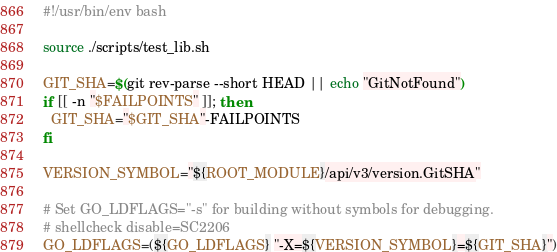Convert code to text. <code><loc_0><loc_0><loc_500><loc_500><_Bash_>#!/usr/bin/env bash

source ./scripts/test_lib.sh

GIT_SHA=$(git rev-parse --short HEAD || echo "GitNotFound")
if [[ -n "$FAILPOINTS" ]]; then
  GIT_SHA="$GIT_SHA"-FAILPOINTS
fi

VERSION_SYMBOL="${ROOT_MODULE}/api/v3/version.GitSHA"

# Set GO_LDFLAGS="-s" for building without symbols for debugging.
# shellcheck disable=SC2206
GO_LDFLAGS=(${GO_LDFLAGS} "-X=${VERSION_SYMBOL}=${GIT_SHA}")</code> 